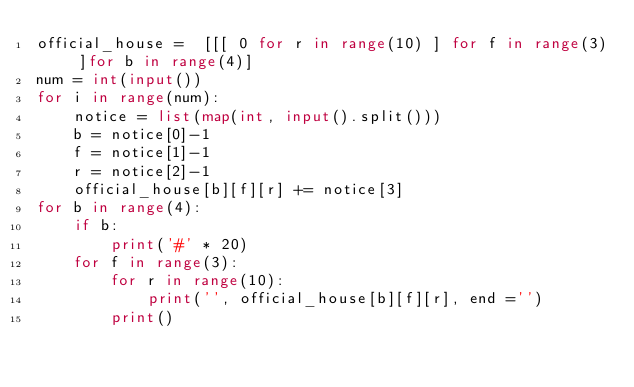<code> <loc_0><loc_0><loc_500><loc_500><_Python_>official_house =  [[[ 0 for r in range(10) ] for f in range(3) ]for b in range(4)]
num = int(input())
for i in range(num):
    notice = list(map(int, input().split()))
    b = notice[0]-1
    f = notice[1]-1
    r = notice[2]-1
    official_house[b][f][r] += notice[3]
for b in range(4):
    if b:
        print('#' * 20)
    for f in range(3):
        for r in range(10):
            print('', official_house[b][f][r], end ='')
        print()
</code> 